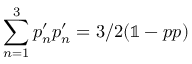<formula> <loc_0><loc_0><loc_500><loc_500>\sum _ { n = 1 } ^ { 3 } p _ { n } ^ { \prime } p _ { n } ^ { \prime } = 3 / 2 ( \mathbb { 1 } - p p )</formula> 